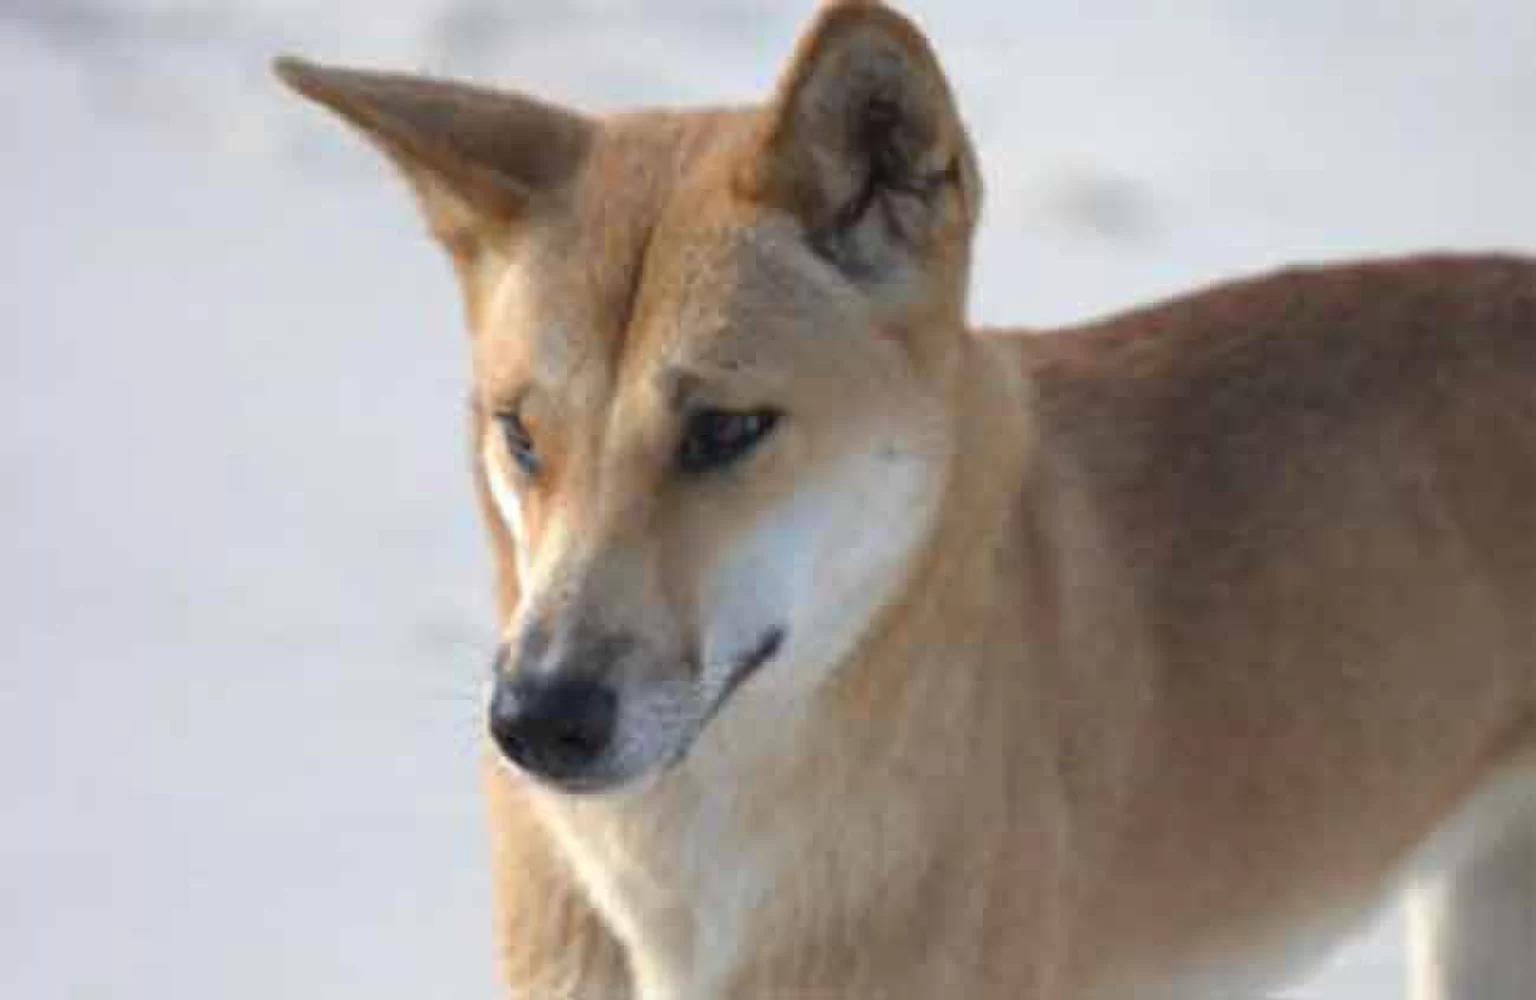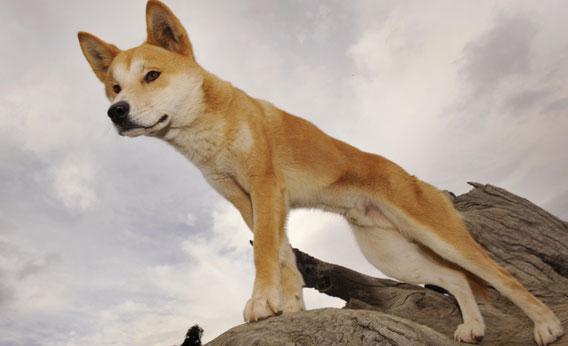The first image is the image on the left, the second image is the image on the right. Evaluate the accuracy of this statement regarding the images: "In at least one image there is a single brown and white dog facing slightly right with there mouth closed.". Is it true? Answer yes or no. Yes. The first image is the image on the left, the second image is the image on the right. Evaluate the accuracy of this statement regarding the images: "The left image shows a dog gazing leftward, and the right image shows a dog whose gaze is more forward.". Is it true? Answer yes or no. No. 